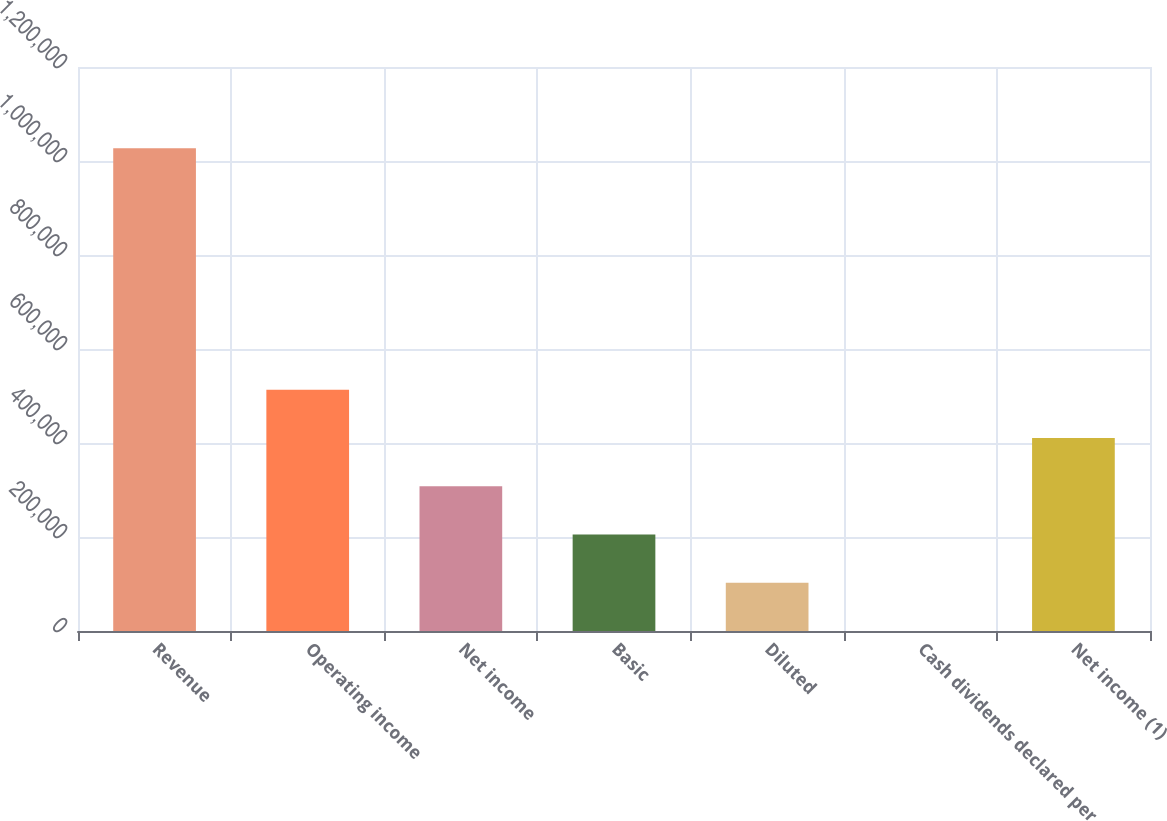Convert chart to OTSL. <chart><loc_0><loc_0><loc_500><loc_500><bar_chart><fcel>Revenue<fcel>Operating income<fcel>Net income<fcel>Basic<fcel>Diluted<fcel>Cash dividends declared per<fcel>Net income (1)<nl><fcel>1.02694e+06<fcel>513472<fcel>308083<fcel>205389<fcel>102695<fcel>0.13<fcel>410778<nl></chart> 